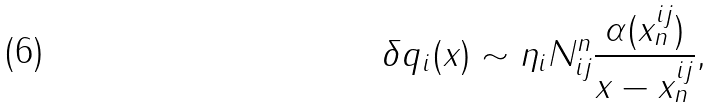Convert formula to latex. <formula><loc_0><loc_0><loc_500><loc_500>\delta q _ { i } ( x ) \sim \eta _ { i } N _ { i j } ^ { n } \frac { \alpha ( x ^ { i j } _ { n } ) } { x - x ^ { i j } _ { n } } ,</formula> 